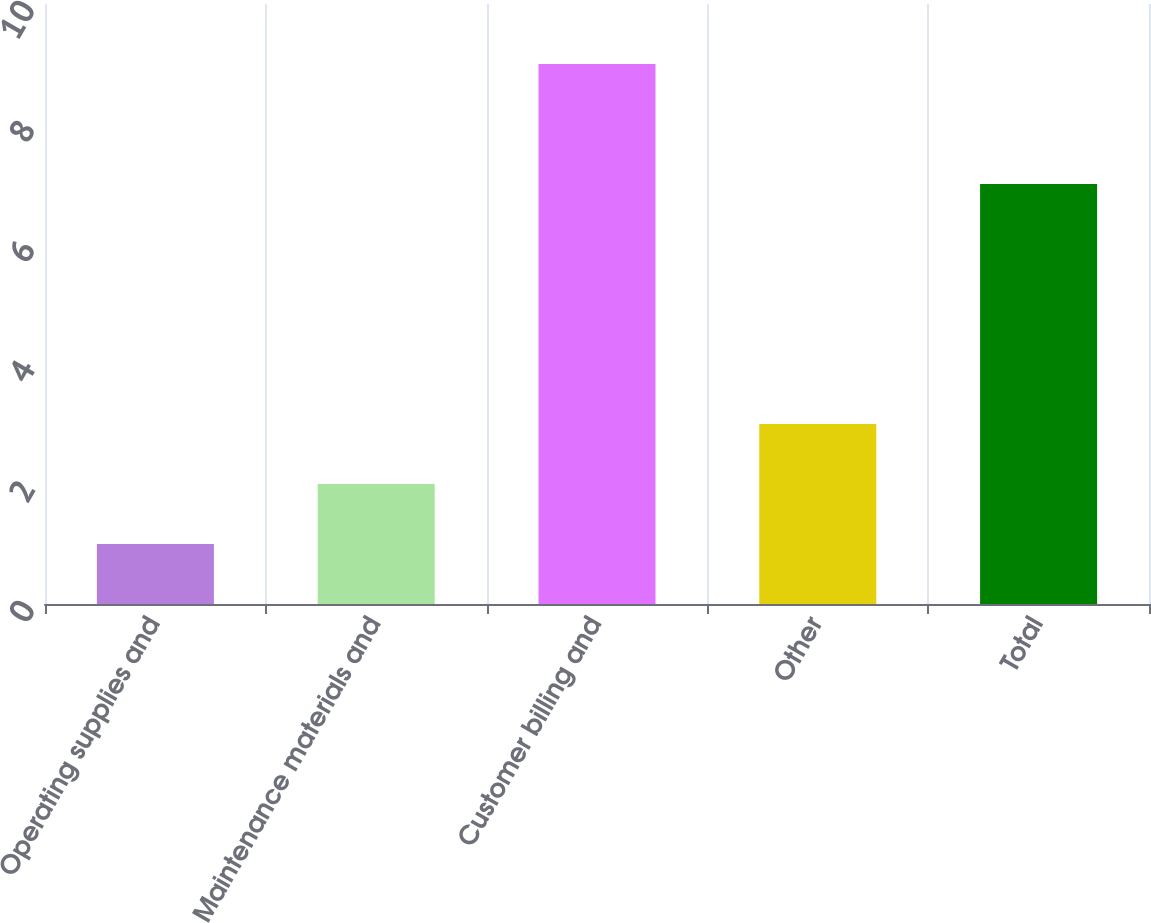Convert chart to OTSL. <chart><loc_0><loc_0><loc_500><loc_500><bar_chart><fcel>Operating supplies and<fcel>Maintenance materials and<fcel>Customer billing and<fcel>Other<fcel>Total<nl><fcel>1<fcel>2<fcel>9<fcel>3<fcel>7<nl></chart> 